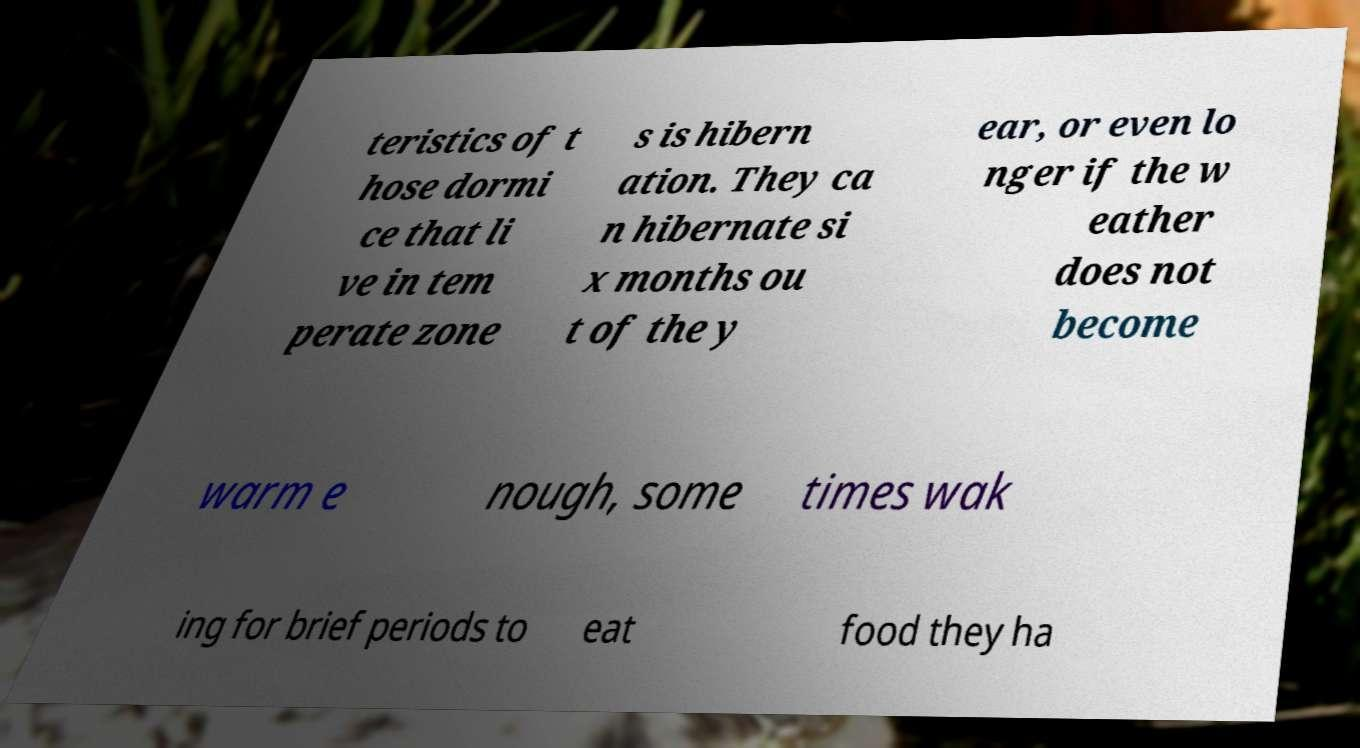Please read and relay the text visible in this image. What does it say? teristics of t hose dormi ce that li ve in tem perate zone s is hibern ation. They ca n hibernate si x months ou t of the y ear, or even lo nger if the w eather does not become warm e nough, some times wak ing for brief periods to eat food they ha 